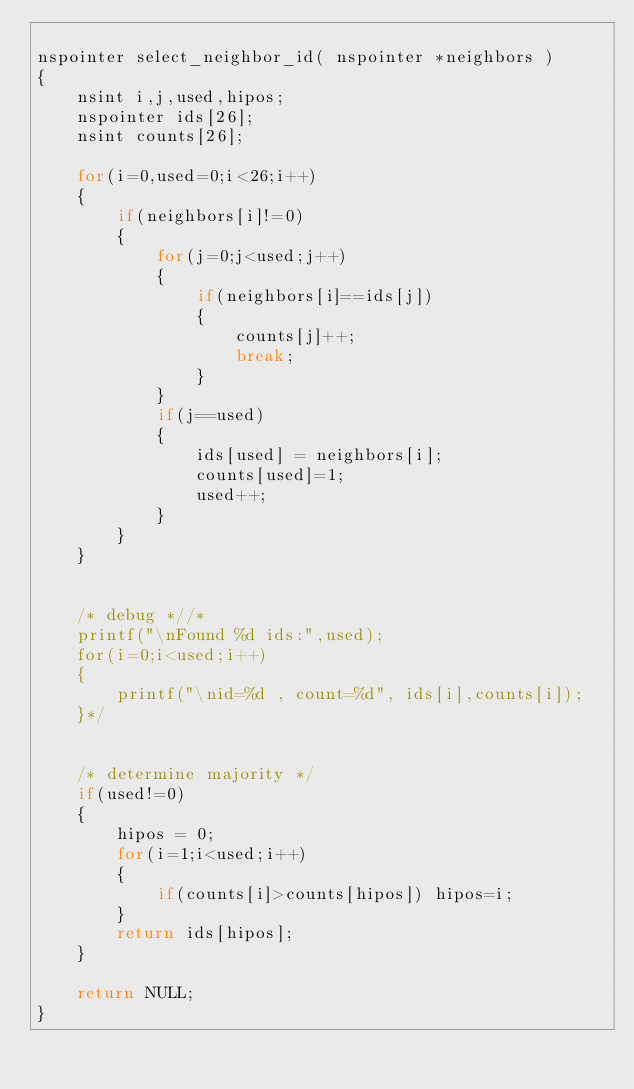Convert code to text. <code><loc_0><loc_0><loc_500><loc_500><_C++_>
nspointer select_neighbor_id( nspointer *neighbors )
{
    nsint i,j,used,hipos;
    nspointer ids[26];
    nsint counts[26];

    for(i=0,used=0;i<26;i++)
    {
        if(neighbors[i]!=0)
        {
            for(j=0;j<used;j++)
            {
                if(neighbors[i]==ids[j])
                {
                    counts[j]++;
                    break;
                }
            }
            if(j==used)
            {
                ids[used] = neighbors[i];
                counts[used]=1;
                used++;
            }
        }
    }


    /* debug *//*
    printf("\nFound %d ids:",used);
    for(i=0;i<used;i++)
    {
        printf("\nid=%d , count=%d", ids[i],counts[i]);
    }*/

    
    /* determine majority */
    if(used!=0)
    {
        hipos = 0;
        for(i=1;i<used;i++)
        {
            if(counts[i]>counts[hipos]) hipos=i;
        }
        return ids[hipos];
    }

    return NULL;
}</code> 